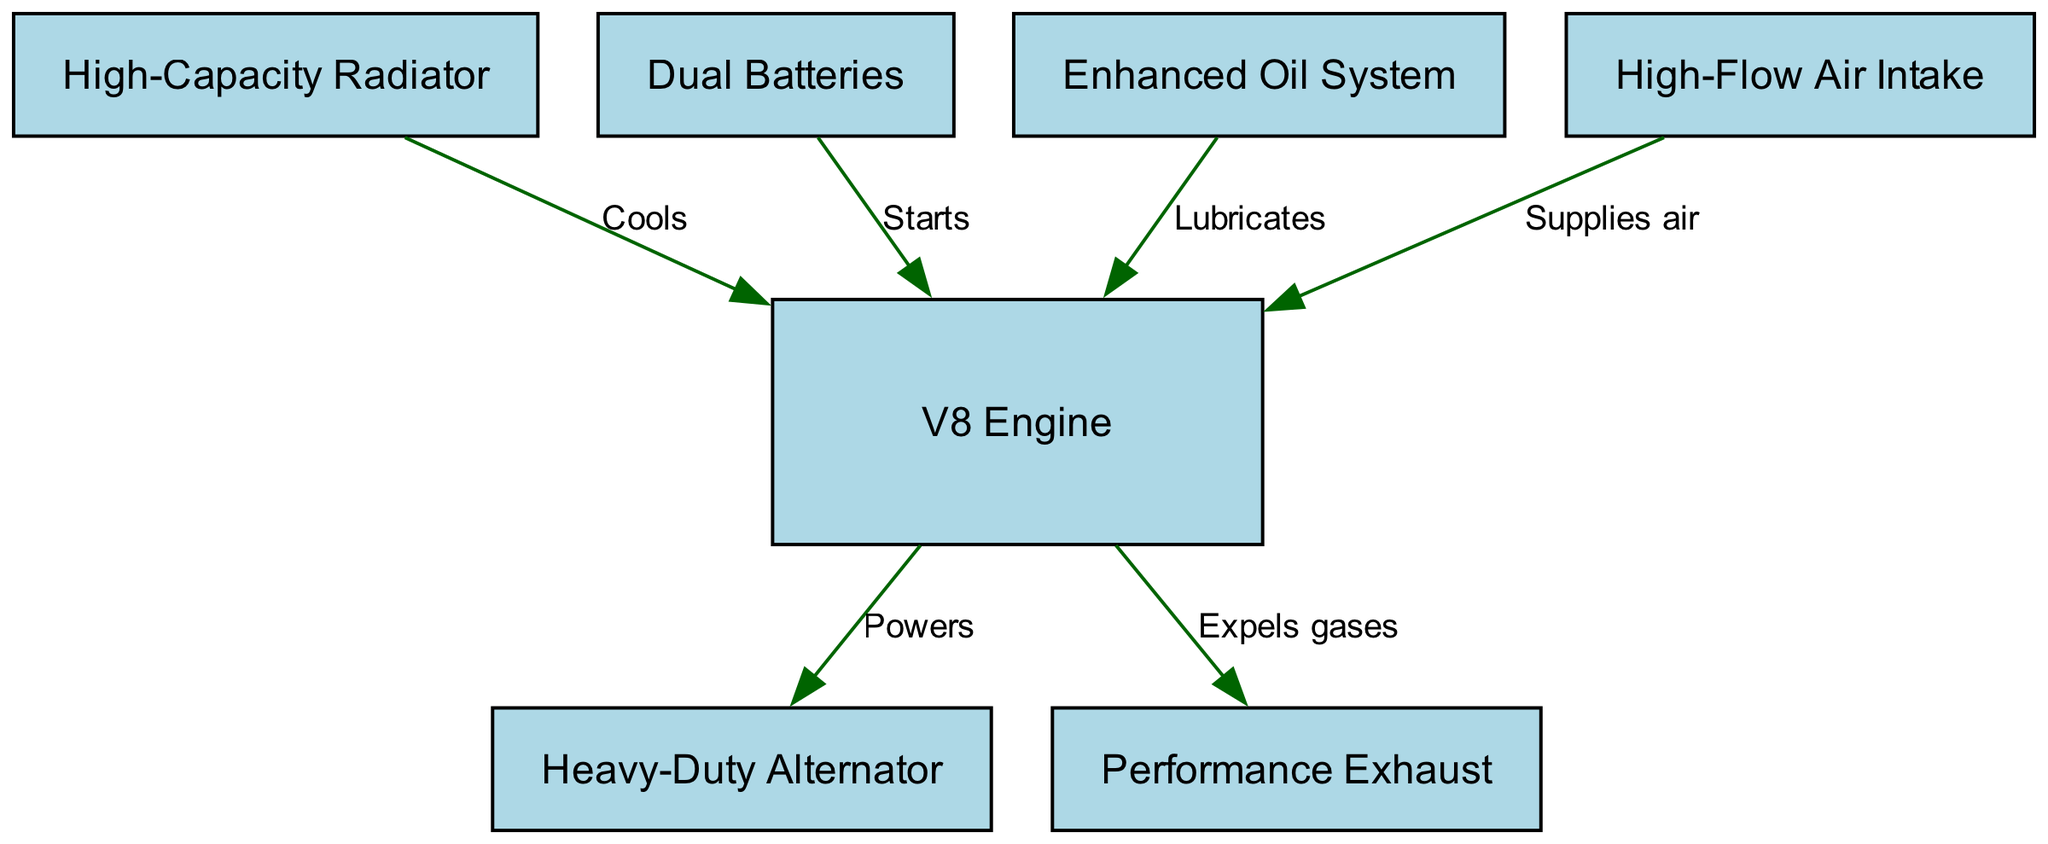What is at the center of the diagram? The diagram's center features the "V8 Engine," which is positioned centrally among the other components. This identifies its primary importance in the engine's functionality.
Answer: V8 Engine How many components are represented in the diagram? The diagram includes a total of 7 nodes representing various engine components, such as the alternator, radiator, battery, oil system, air intake, and exhaust, along with the engine itself.
Answer: 7 What powers the heavy-duty alternator? According to the diagram, the arrow indicates that the "V8 Engine" powers the "Heavy-Duty Alternator," establishing a direct relationship of support between these two components in the engine system.
Answer: V8 Engine Which component supplies air to the engine? The "High-Flow Air Intake" is explicitly indicated in the diagram as the component responsible for supplying air to the "V8 Engine," as denoted by an arrow linking these two components.
Answer: High-Flow Air Intake What is the purpose of the radiator in relation to the engine? The diagram specifies that the "High-Capacity Radiator" is responsible for cooling the "V8 Engine," highlighting its crucial role in maintaining optimal operating temperatures during operation.
Answer: Cools Which component expels gases from the engine? The "Performance Exhaust" is illustrated in the diagram as the component that receives gases from the "V8 Engine" and expels them, forming an essential part of the engine's exhaust system.
Answer: Performance Exhaust What do the dual batteries do for the engine? According to the diagram, the dual batteries are shown to play a vital role by starting the "V8 Engine," indicating their importance in the engine's ignition process.
Answer: Starts What lubricates the V8 Engine? The "Enhanced Oil System" is the component designated in the diagram to lubricate the "V8 Engine," ensuring its smooth operation and longevity by minimizing friction.
Answer: Lubricates How many relationships are shown between the engine components in the diagram? The diagram depicts a total of 6 directional relationships (edges) between the engine components, illustrating how they interact with each other in the engine system.
Answer: 6 